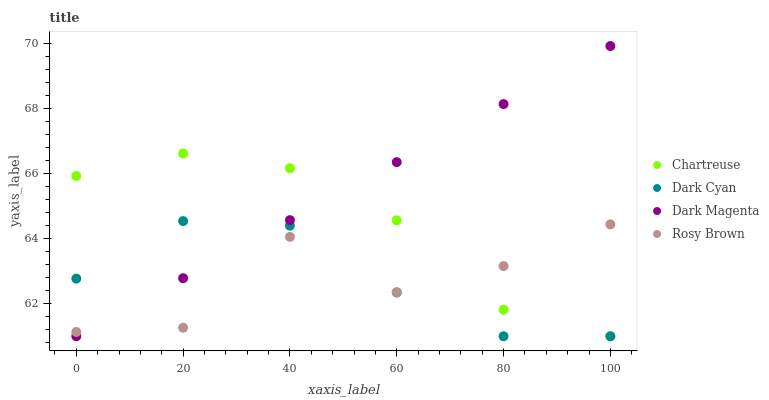Does Rosy Brown have the minimum area under the curve?
Answer yes or no. Yes. Does Dark Magenta have the maximum area under the curve?
Answer yes or no. Yes. Does Chartreuse have the minimum area under the curve?
Answer yes or no. No. Does Chartreuse have the maximum area under the curve?
Answer yes or no. No. Is Dark Magenta the smoothest?
Answer yes or no. Yes. Is Rosy Brown the roughest?
Answer yes or no. Yes. Is Chartreuse the smoothest?
Answer yes or no. No. Is Chartreuse the roughest?
Answer yes or no. No. Does Dark Cyan have the lowest value?
Answer yes or no. Yes. Does Rosy Brown have the lowest value?
Answer yes or no. No. Does Dark Magenta have the highest value?
Answer yes or no. Yes. Does Chartreuse have the highest value?
Answer yes or no. No. Does Dark Cyan intersect Dark Magenta?
Answer yes or no. Yes. Is Dark Cyan less than Dark Magenta?
Answer yes or no. No. Is Dark Cyan greater than Dark Magenta?
Answer yes or no. No. 